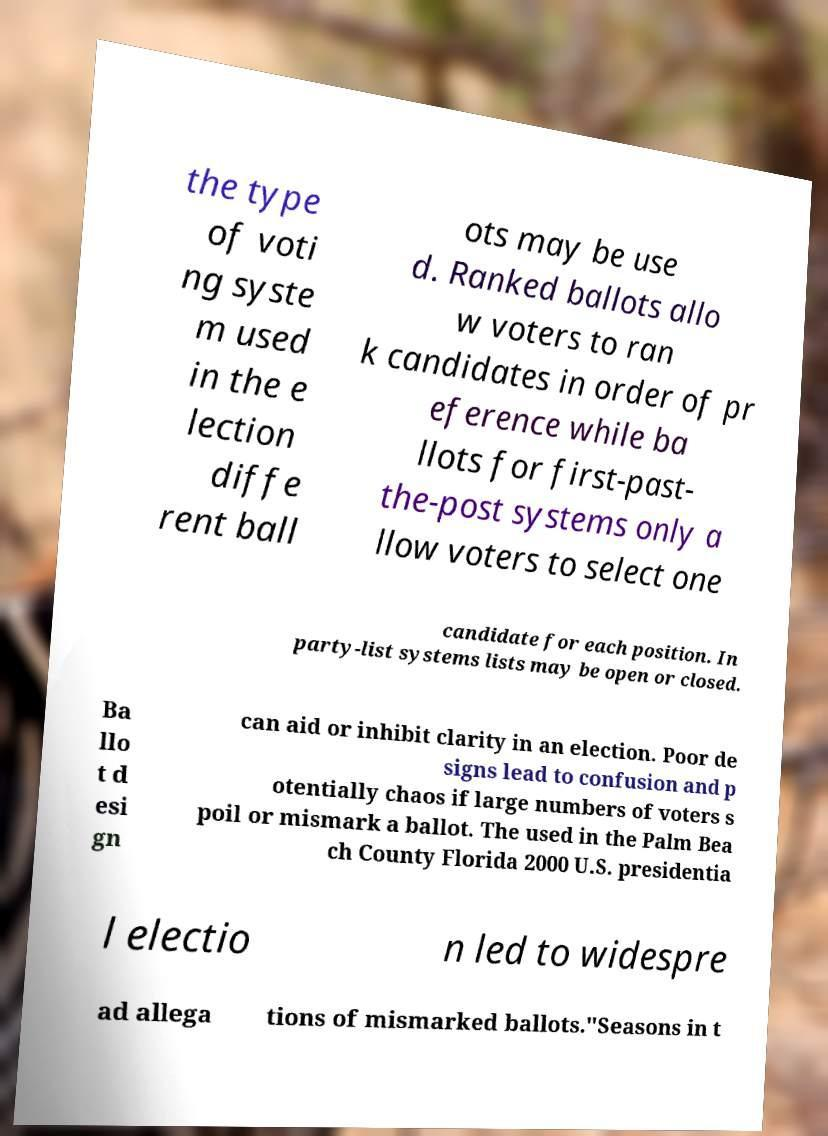I need the written content from this picture converted into text. Can you do that? the type of voti ng syste m used in the e lection diffe rent ball ots may be use d. Ranked ballots allo w voters to ran k candidates in order of pr eference while ba llots for first-past- the-post systems only a llow voters to select one candidate for each position. In party-list systems lists may be open or closed. Ba llo t d esi gn can aid or inhibit clarity in an election. Poor de signs lead to confusion and p otentially chaos if large numbers of voters s poil or mismark a ballot. The used in the Palm Bea ch County Florida 2000 U.S. presidentia l electio n led to widespre ad allega tions of mismarked ballots."Seasons in t 